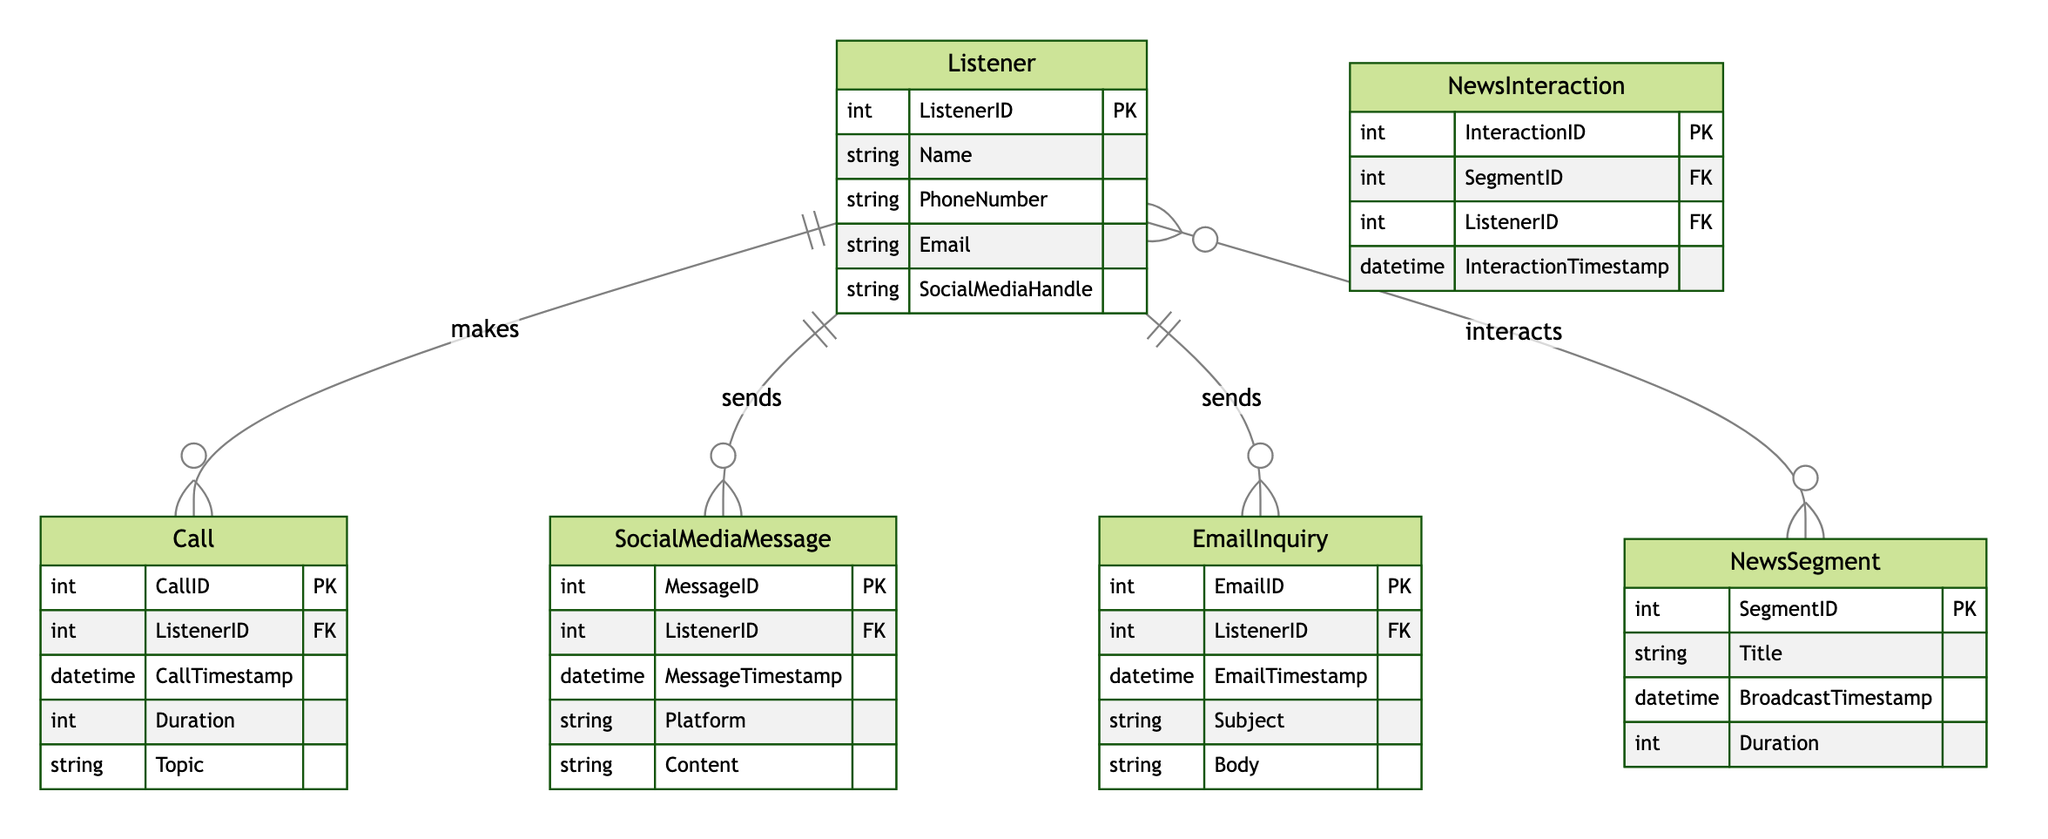What is the primary key of the Listener entity? The primary key of the Listener entity is ListenerID, as indicated in the diagram where it is defined as the unique identifier for the Listener.
Answer: ListenerID How many interactions can a Listener have? According to the diagram, a Listener can have multiple interactions with Calls, Social Media Messages, and Email Inquiries. Thus, it is described as one-to-many, indicating unlimited interactions.
Answer: Multiple What is the relationship type between Listener and Call? The diagram shows that the relationship between Listener and Call is one-to-many. This indicates a single Listener can have multiple Calls associated with them.
Answer: One-To-Many How many primary keys are defined in the NewsInteraction entity? The NewsInteraction entity has one primary key, which is InteractionID as shown in the diagram, with the role of uniquely identifying each interaction.
Answer: One What is the foreign key in the SocialMediaMessage entity? The SocialMediaMessage entity has ListenerID as a foreign key, which links it to the Listener entity, as per the diagram's structure connecting listeners to their messages.
Answer: ListenerID What is the description of the NewsInteraction relationship? The diagram describes the NewsInteraction relationship as a many-to-many relationship, indicating that multiple listeners can interact with multiple news segments.
Answer: Many-To-Many What type of data is stored in the Duration attribute of the Call entity? The Duration attribute of the Call entity is defined as an Integer data type in the diagram, indicating that it stores whole number values representing the duration of the call.
Answer: Integer What does the EmailTimestamp attribute represent? The EmailTimestamp attribute in the EmailInquiry entity represents the date and time when the email inquiry was sent, as indicated by its definition in the diagram.
Answer: Date and Time Which entity has the attribute Content? The attribute Content is associated with the SocialMediaMessage entity, as shown in the diagram where it specifies the content of each message sent by the listener.
Answer: SocialMediaMessage 